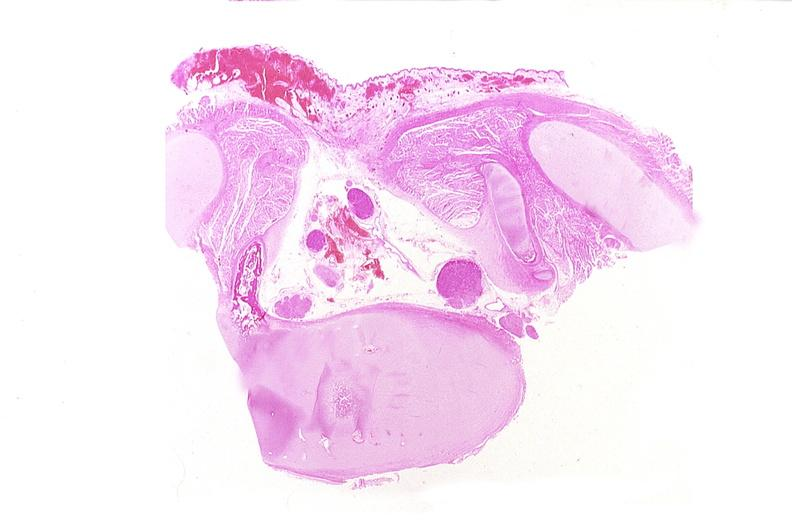s nervous present?
Answer the question using a single word or phrase. Yes 